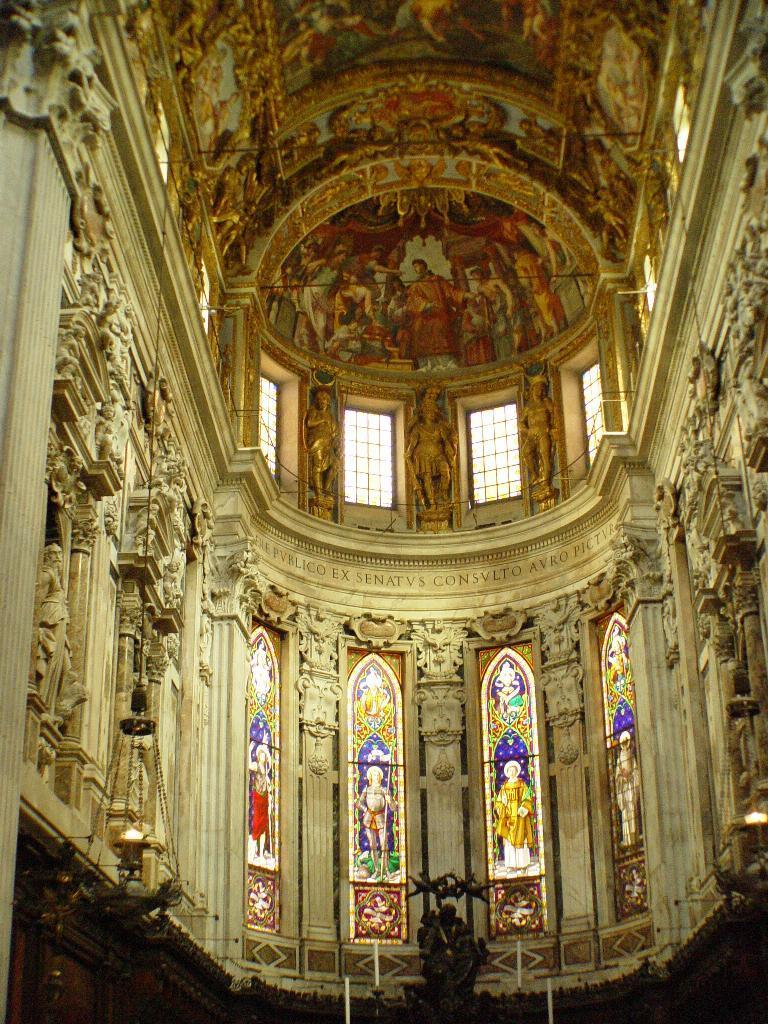What type of structure is depicted in the image? The image shows an internal structure of a building. What is the uppermost part of the building visible in the image? There is a roof visible in the image. What architectural feature allows light and air into the building? There are windows in the image. What type of decoration or artwork is present in the image? There are pictures of people wearing clothes in the image. Can you tell me how many dogs are present in the image? There are no dogs present in the image; it shows an internal structure of a building with pictures of people wearing clothes. 